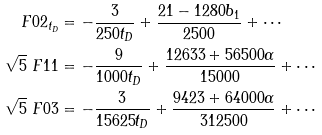Convert formula to latex. <formula><loc_0><loc_0><loc_500><loc_500>\ F 0 2 _ { t _ { D } } & = - \frac { 3 } { 2 5 0 t _ { D } } + \frac { 2 1 - 1 2 8 0 b _ { 1 } } { 2 5 0 0 } + \cdots \\ \sqrt { 5 } \ F 1 1 & = - \frac { 9 } { 1 0 0 0 t _ { D } } + \frac { 1 2 6 3 3 + 5 6 5 0 0 \alpha } { 1 5 0 0 0 } + \cdots \\ \sqrt { 5 } \ F 0 3 & = - \frac { 3 } { 1 5 6 2 5 t _ { D } } + \frac { 9 4 2 3 + 6 4 0 0 0 \alpha } { 3 1 2 5 0 0 } + \cdots</formula> 